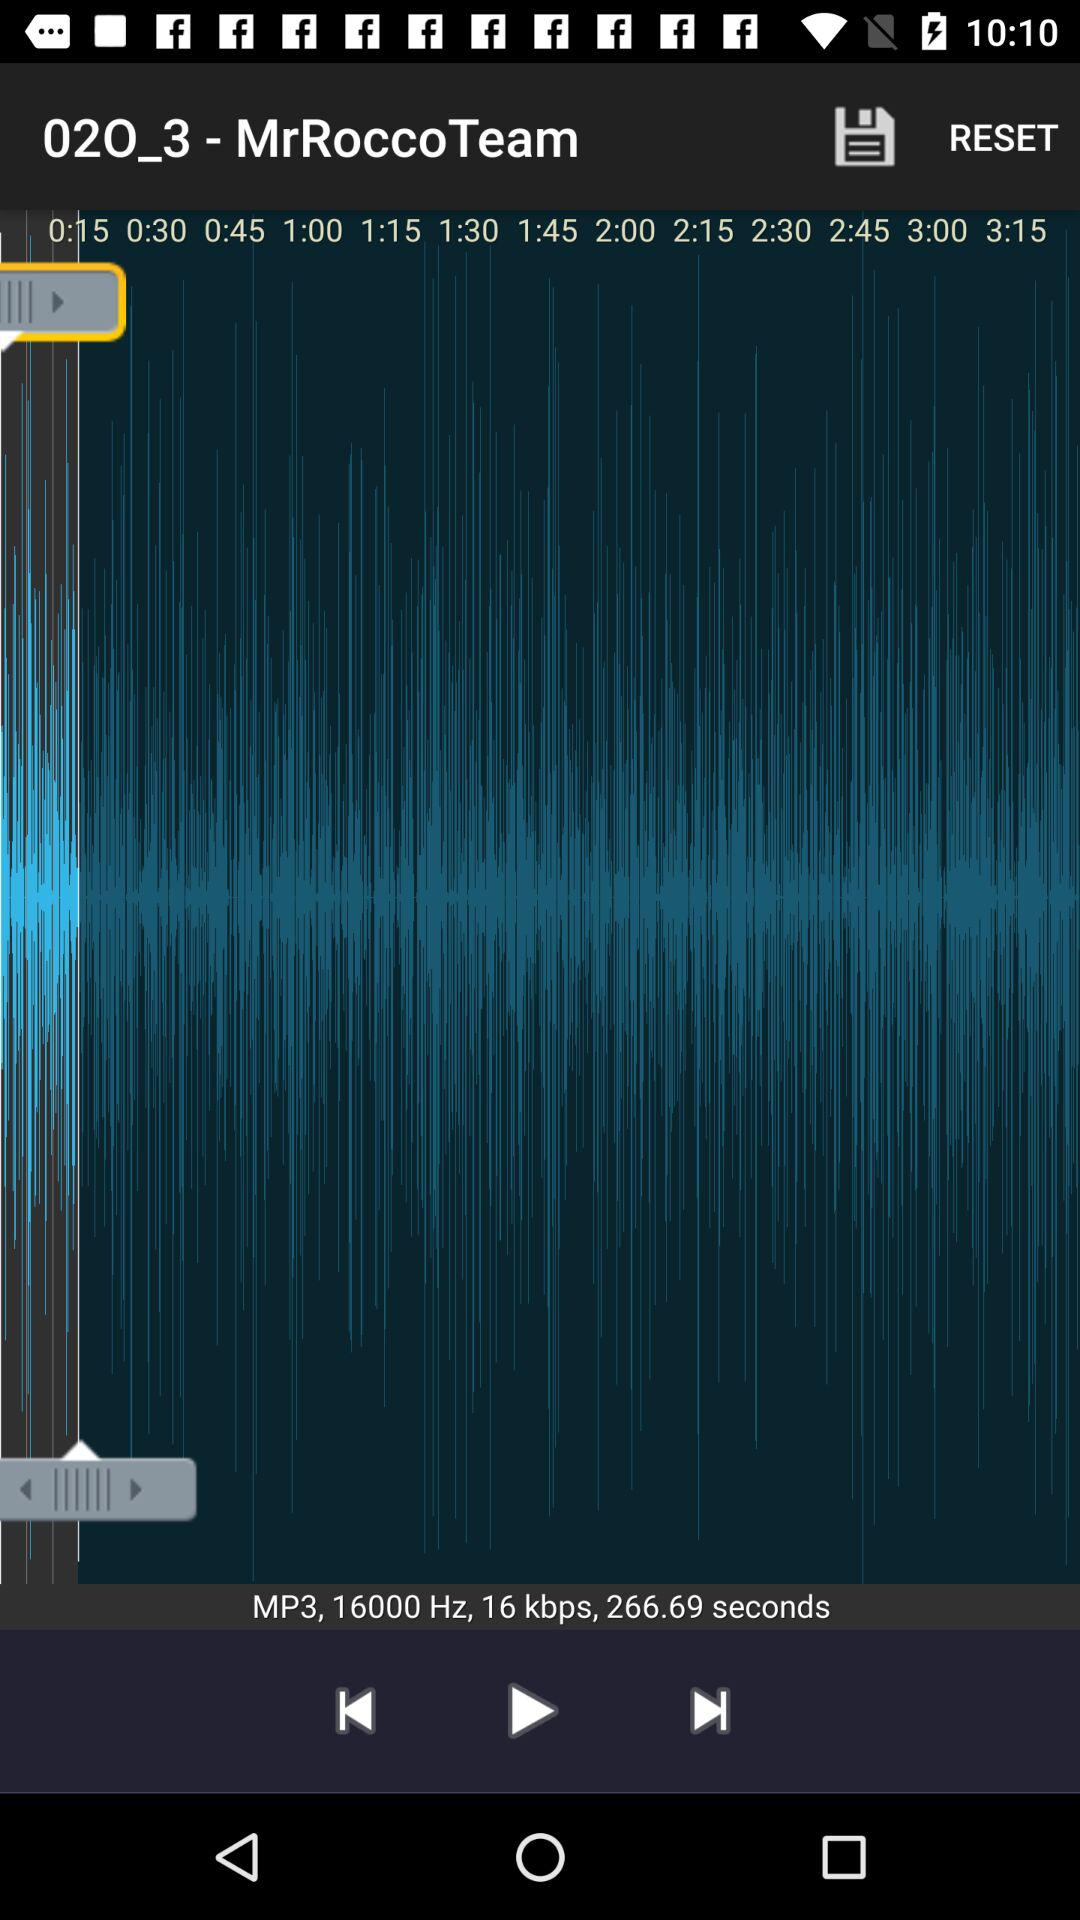How long is the audio? The audio is 266.69 seconds long. 